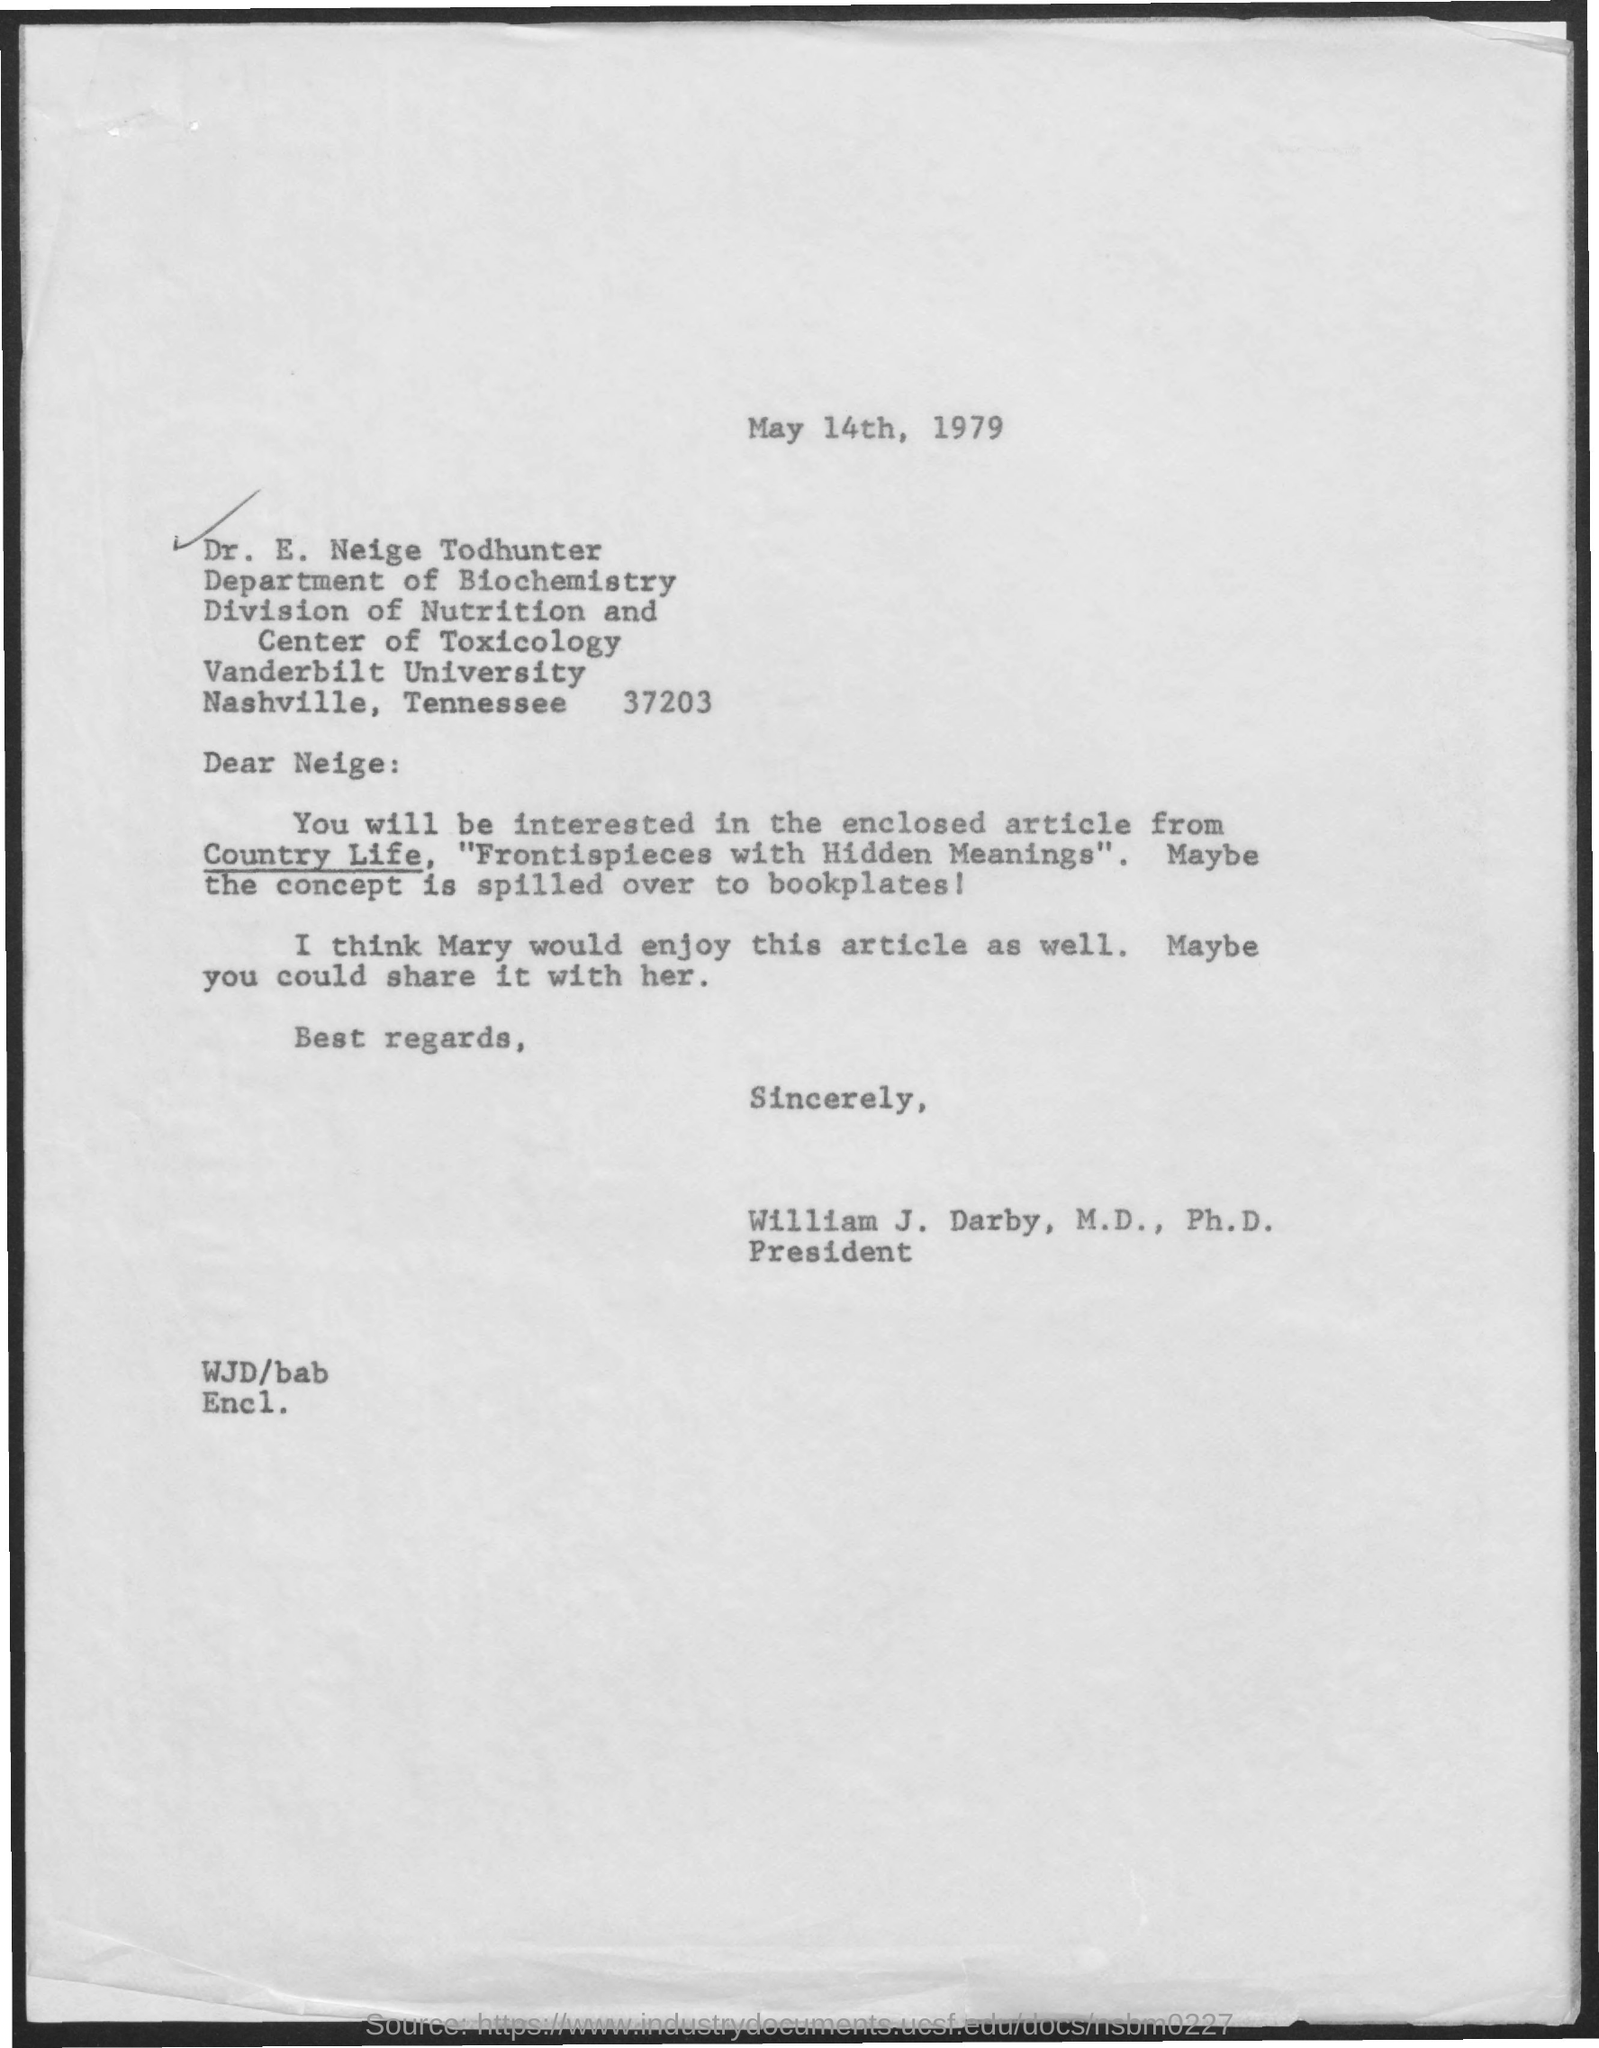What is the date mentioned ?
Provide a succinct answer. May 14th, 1979. To which department he belongs to ?
Your answer should be compact. Department of biochemistry. What is the name of the university ?
Provide a short and direct response. Vanderbilt university. Who is the president ?
Your response must be concise. William J. Darby, M,D., Ph.D. Who would enjoy this article as well ?
Your answer should be compact. Mary. 